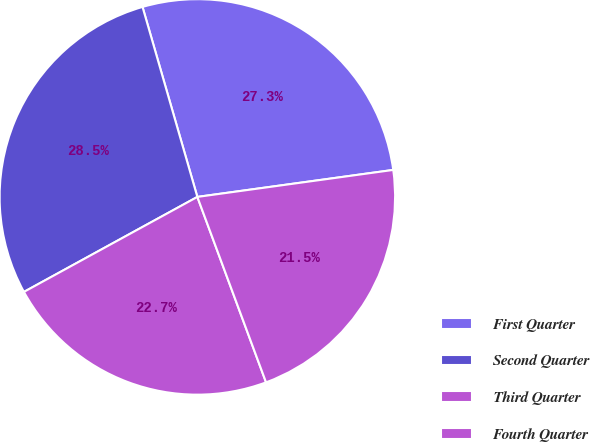Convert chart. <chart><loc_0><loc_0><loc_500><loc_500><pie_chart><fcel>First Quarter<fcel>Second Quarter<fcel>Third Quarter<fcel>Fourth Quarter<nl><fcel>27.29%<fcel>28.5%<fcel>22.67%<fcel>21.53%<nl></chart> 